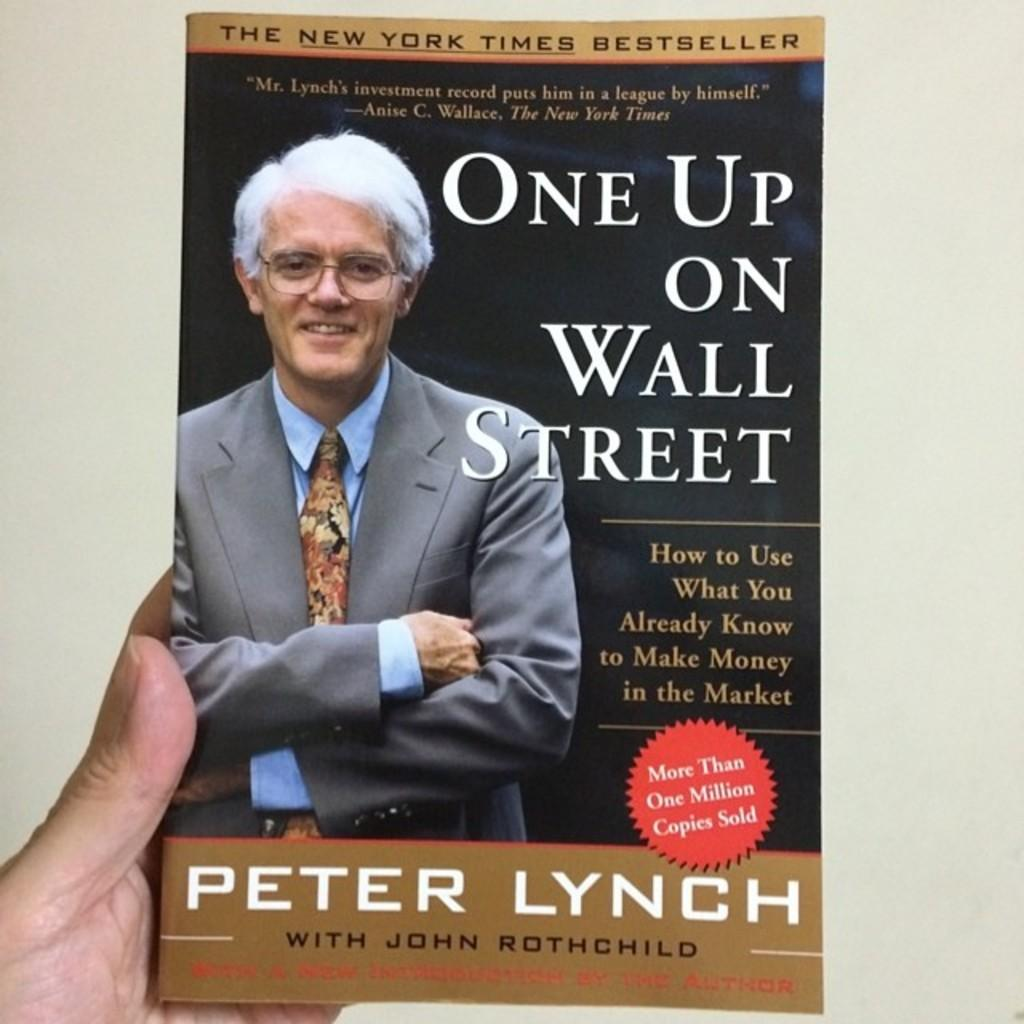What is the person in the image holding? The person is holding a book in the image. What can be seen on the cover of the book? The book has a picture of a person on it. Is there any text on the book? Yes, there is writing on the book. What type of nail is being used to hold the book open in the image? There is no nail present in the image, and the book is not being held open. 